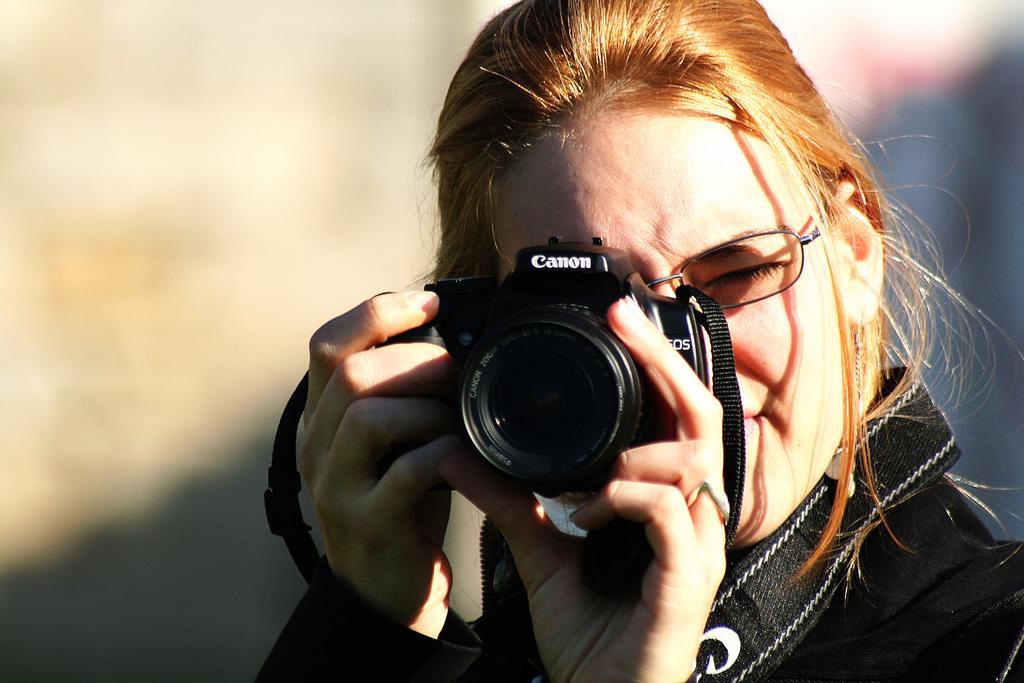Could you give a brief overview of what you see in this image? In this image I can see a person wearing specs and holding the camera. 